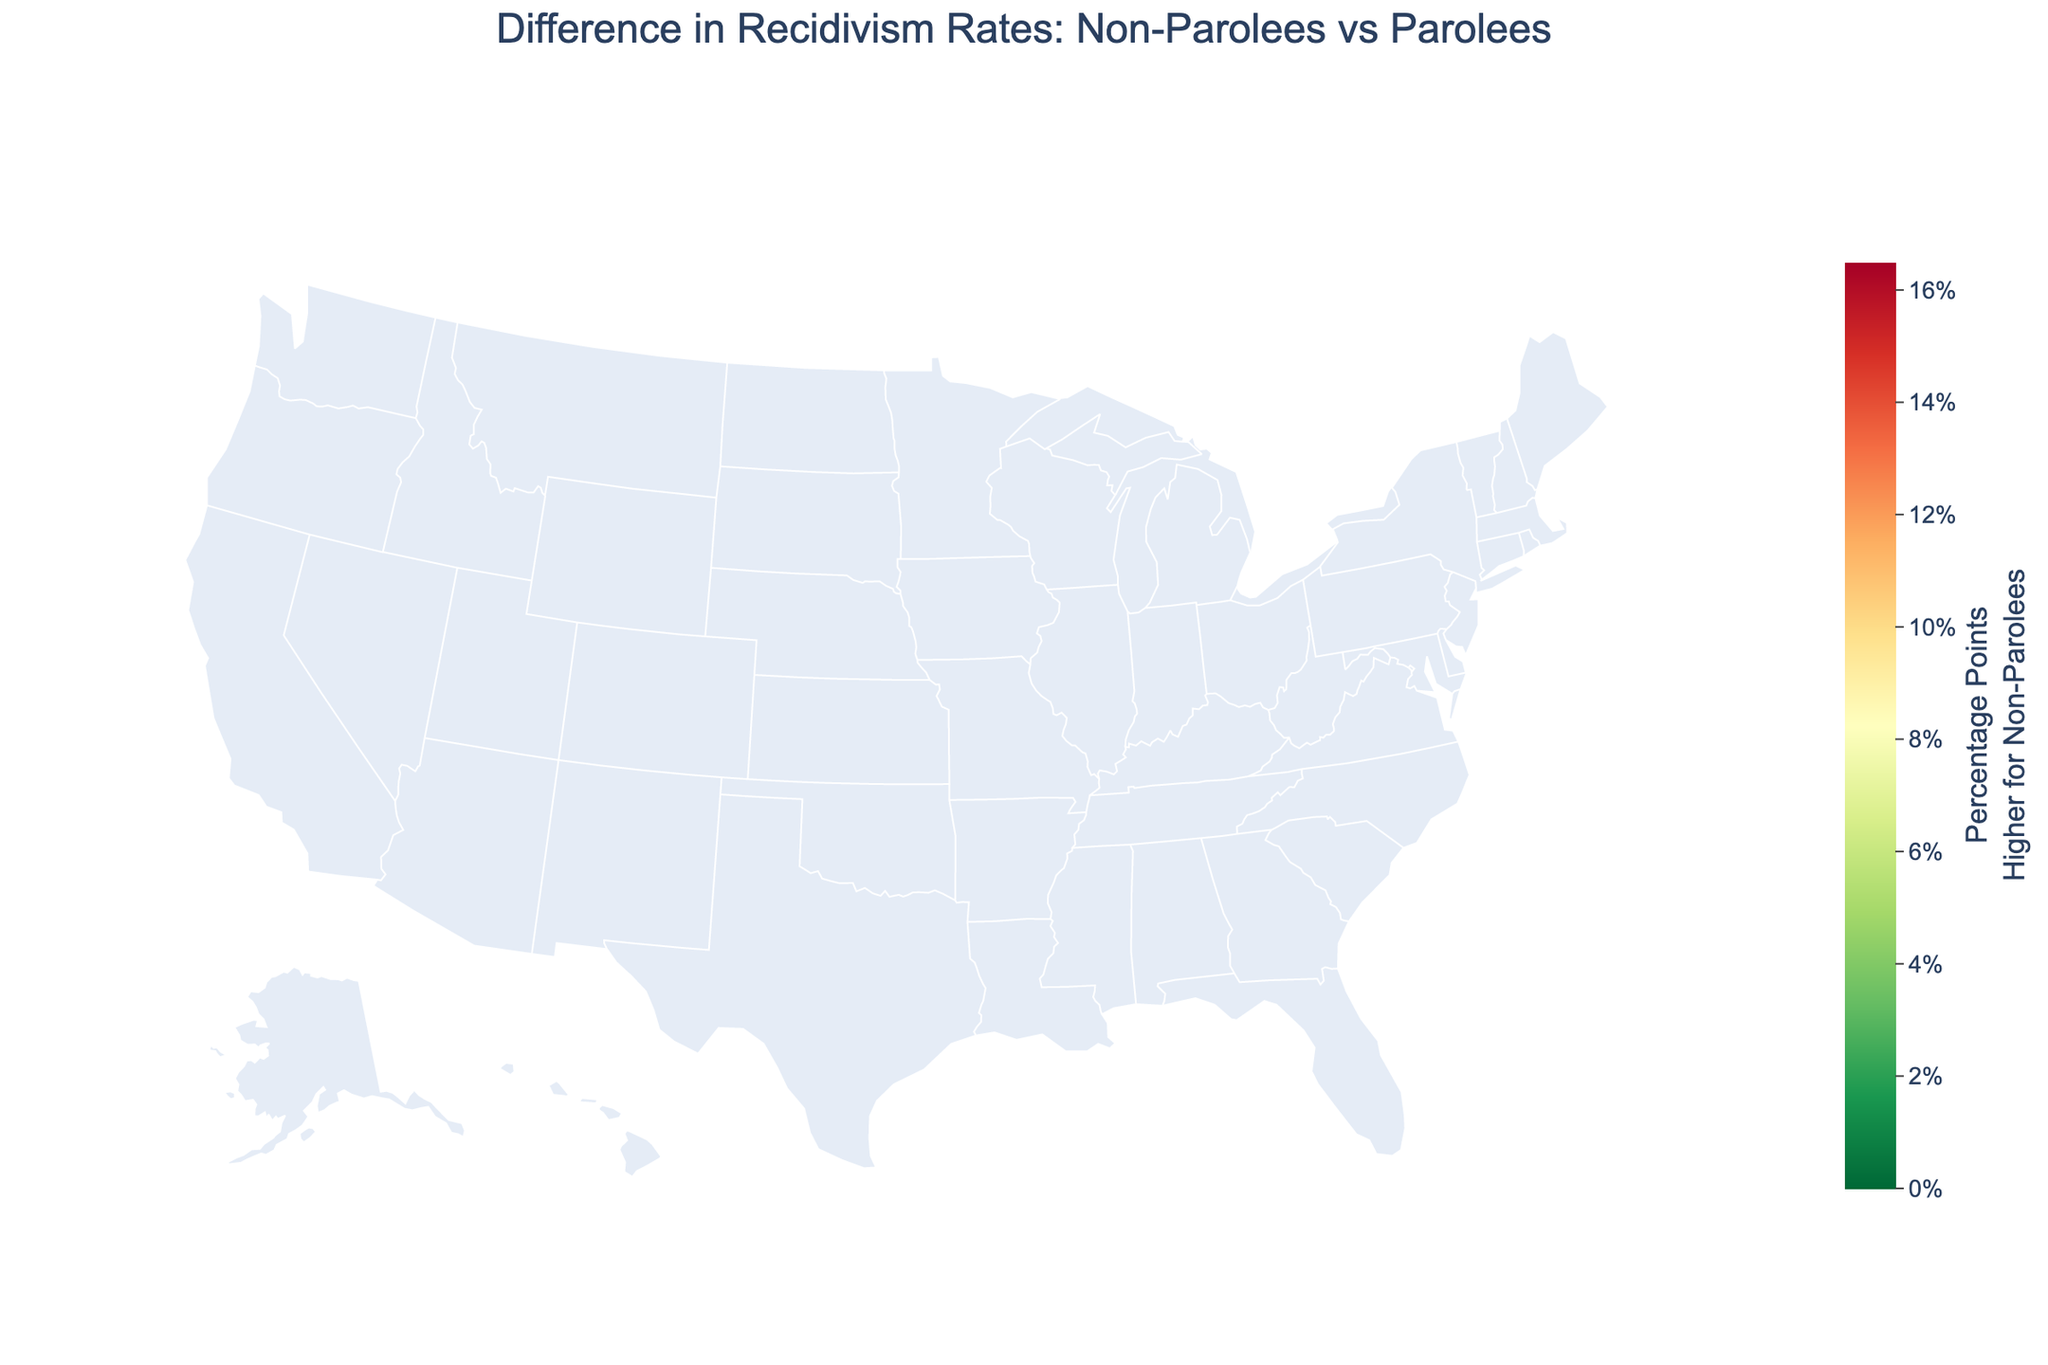What's the title of the figure? The title of the figure is displayed at the top center of the plot.
Answer: Difference in Recidivism Rates: Non-Parolees vs Parolees How many states are shown in the figure? The figure includes data for each state represented on the choropleth map. By counting the number of entries in the data or visually checking, there are 20 states depicted.
Answer: 20 Which state has the largest difference in recidivism rates between non-parolees and parolees? The figure uses a color scale to represent the difference in recidivism rates. The state with the darkest color corresponding to the highest value will have the largest difference.
Answer: California What is the recidivism rate for parolees in New York? The recidivism rate for parolees in New York is accessible by hovering over New York on the plot, which reveals the detailed data.
Answer: 39.1% By how many percentage points do non-parolees exceed the recidivism rate of parolees in Illinois? The difference in recidivism rates is visually encoded in color, and the exact value can be found by either looking at the legend or the hover data for Illinois.
Answer: 15.5 percentage points Which state shows the smallest difference in recidivism rates between non-parolees and parolees? The state with the lightest color on the plot corresponds to the smallest difference in recidivism.
Answer: Florida Are there any states where the recidivism rate for parolees is higher than for non-parolees? The plot subtitle and color scale's annotation clarifies that positive values indicate higher rates for non-parolees. Therefore, no state will have a negative difference if the plot only shows positive values.
Answer: No What's the average recidivism rate difference between non-parolees and parolees across all states? To calculate the average, sum the differences in recidivism rates for all states and divide by the number of states. (15.5 + 15.4 + 15.4 + 16.5 + 15.5 + ...) / 20 = 17.17
Answer: 17.17 percentage points Which state has the second highest difference in recidivism rates? After identifying California as the state with the highest difference, use the next darkest shade to find the second highest difference, often displayed in the hover data or color intensity.
Answer: Pennsylvania 